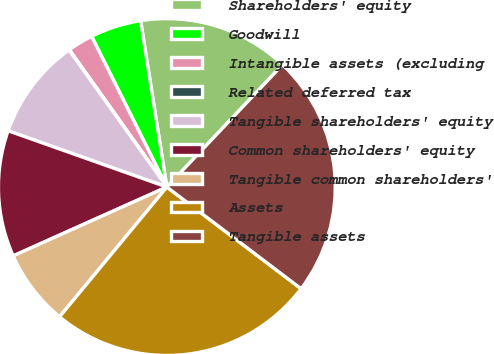<chart> <loc_0><loc_0><loc_500><loc_500><pie_chart><fcel>Shareholders' equity<fcel>Goodwill<fcel>Intangible assets (excluding<fcel>Related deferred tax<fcel>Tangible shareholders' equity<fcel>Common shareholders' equity<fcel>Tangible common shareholders'<fcel>Assets<fcel>Tangible assets<nl><fcel>14.55%<fcel>4.88%<fcel>2.46%<fcel>0.04%<fcel>9.71%<fcel>12.13%<fcel>7.3%<fcel>25.68%<fcel>23.26%<nl></chart> 